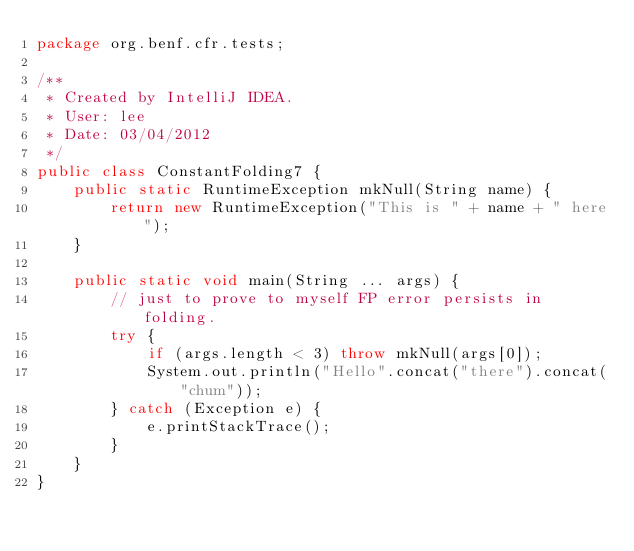<code> <loc_0><loc_0><loc_500><loc_500><_Java_>package org.benf.cfr.tests;

/**
 * Created by IntelliJ IDEA.
 * User: lee
 * Date: 03/04/2012
 */
public class ConstantFolding7 {
    public static RuntimeException mkNull(String name) {
        return new RuntimeException("This is " + name + " here");
    }

    public static void main(String ... args) {
        // just to prove to myself FP error persists in folding.
        try {
            if (args.length < 3) throw mkNull(args[0]);
            System.out.println("Hello".concat("there").concat("chum"));
        } catch (Exception e) {
            e.printStackTrace();
        }
    }
}
</code> 